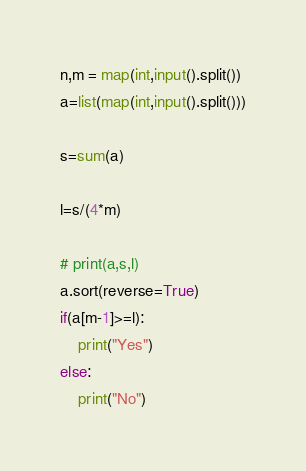Convert code to text. <code><loc_0><loc_0><loc_500><loc_500><_Python_>n,m = map(int,input().split())
a=list(map(int,input().split()))

s=sum(a)

l=s/(4*m)

# print(a,s,l)
a.sort(reverse=True)
if(a[m-1]>=l):
    print("Yes")
else:
    print("No")</code> 